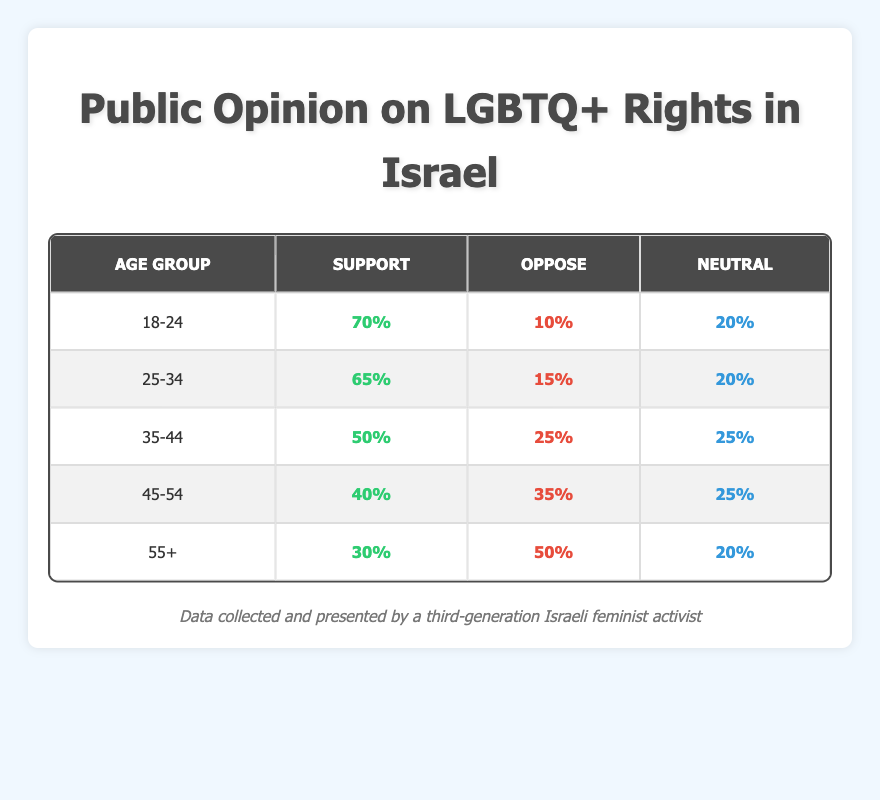What percentage of the 18-24 age group supports LGBTQ+ rights? According to the table, the support percentage for the 18-24 age group is directly stated as 70%.
Answer: 70% How many age groups have more than 50% support for LGBTQ+ rights? The age groups are 18-24 (70%) and 25-34 (65%). Thus, there are two age groups with more than 50% support.
Answer: 2 Is it true that the 55+ age group has more people opposed to LGBTQ+ rights than supportive? The 55+ age group shows 30% support and 50% oppose. Since 50% is greater than 30%, this statement is true.
Answer: Yes What is the average percentage of support across all age groups? Calculating the average requires summing the support percentages: 70 + 65 + 50 + 40 + 30 = 255. With 5 age groups, the average is 255 / 5 = 51.
Answer: 51% Which age group has the highest percentage of opposition to LGBTQ+ rights? Upon examining the table, the 55+ age group has the highest opposition percentages at 50%.
Answer: 55+ 